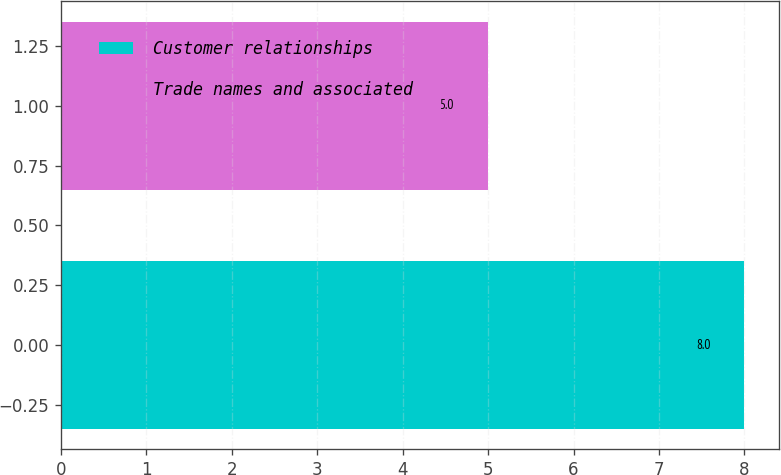<chart> <loc_0><loc_0><loc_500><loc_500><bar_chart><fcel>Customer relationships<fcel>Trade names and associated<nl><fcel>8<fcel>5<nl></chart> 